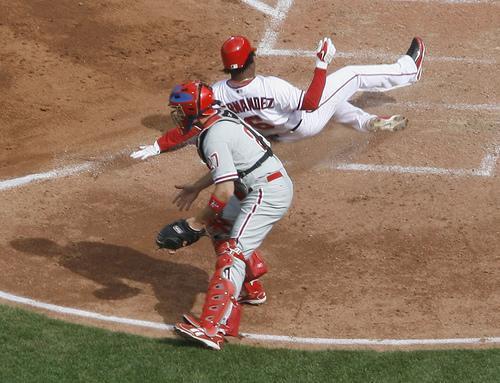How many people are in the photo?
Give a very brief answer. 2. 